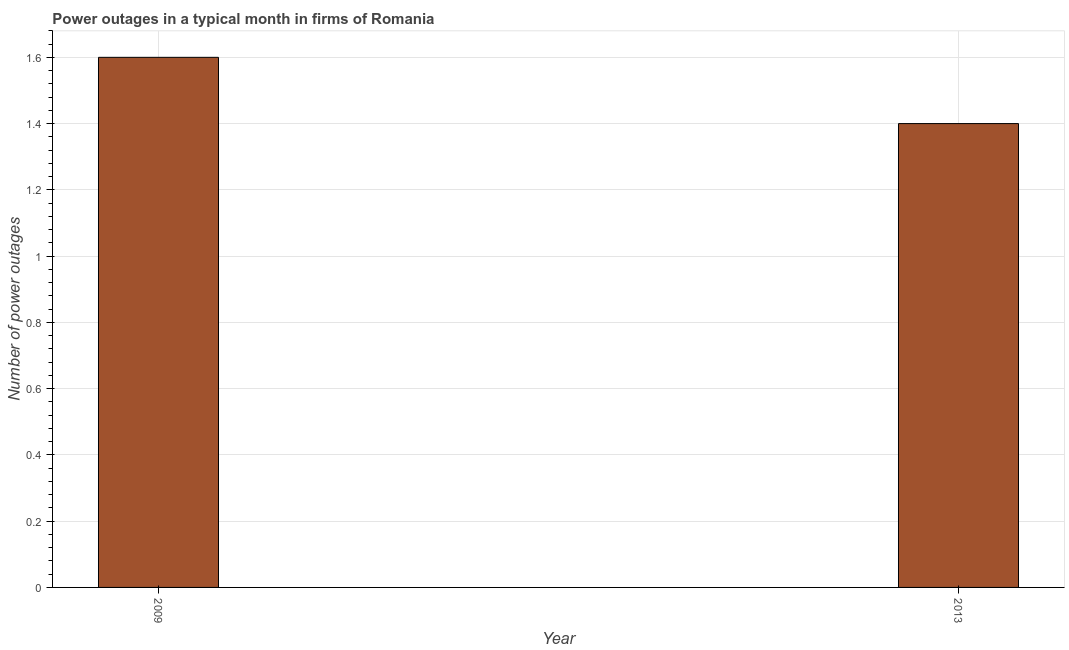What is the title of the graph?
Give a very brief answer. Power outages in a typical month in firms of Romania. What is the label or title of the X-axis?
Provide a succinct answer. Year. What is the label or title of the Y-axis?
Keep it short and to the point. Number of power outages. What is the number of power outages in 2009?
Offer a terse response. 1.6. In which year was the number of power outages minimum?
Provide a short and direct response. 2013. What is the sum of the number of power outages?
Keep it short and to the point. 3. What is the average number of power outages per year?
Offer a very short reply. 1.5. What is the median number of power outages?
Make the answer very short. 1.5. In how many years, is the number of power outages greater than 1.64 ?
Ensure brevity in your answer.  0. Do a majority of the years between 2009 and 2013 (inclusive) have number of power outages greater than 1.08 ?
Give a very brief answer. Yes. What is the ratio of the number of power outages in 2009 to that in 2013?
Ensure brevity in your answer.  1.14. In how many years, is the number of power outages greater than the average number of power outages taken over all years?
Your answer should be very brief. 1. How many bars are there?
Ensure brevity in your answer.  2. What is the difference between two consecutive major ticks on the Y-axis?
Keep it short and to the point. 0.2. Are the values on the major ticks of Y-axis written in scientific E-notation?
Ensure brevity in your answer.  No. What is the ratio of the Number of power outages in 2009 to that in 2013?
Your answer should be very brief. 1.14. 